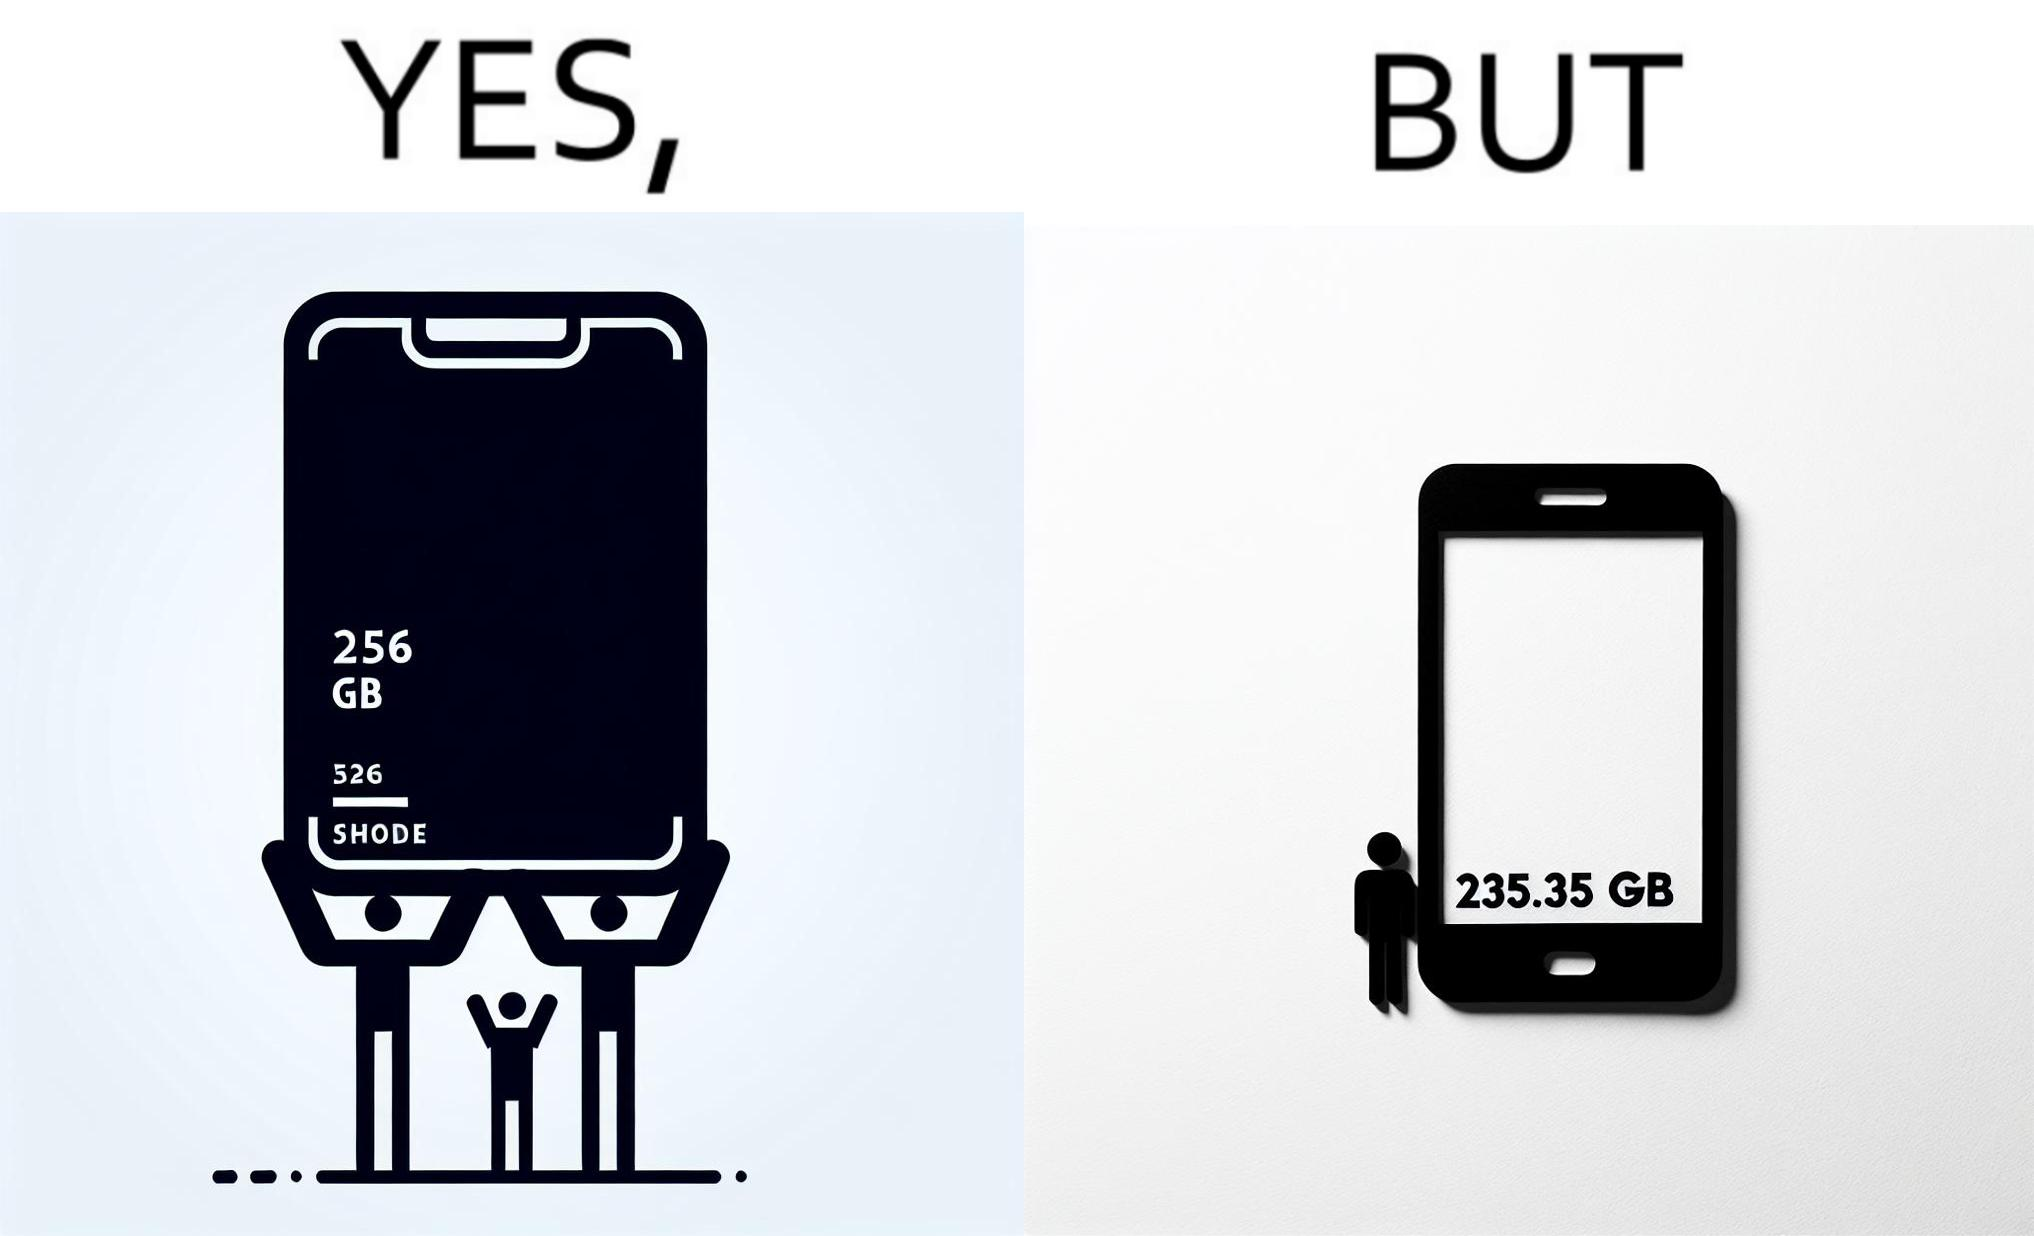Is this image satirical or non-satirical? Yes, this image is satirical. 